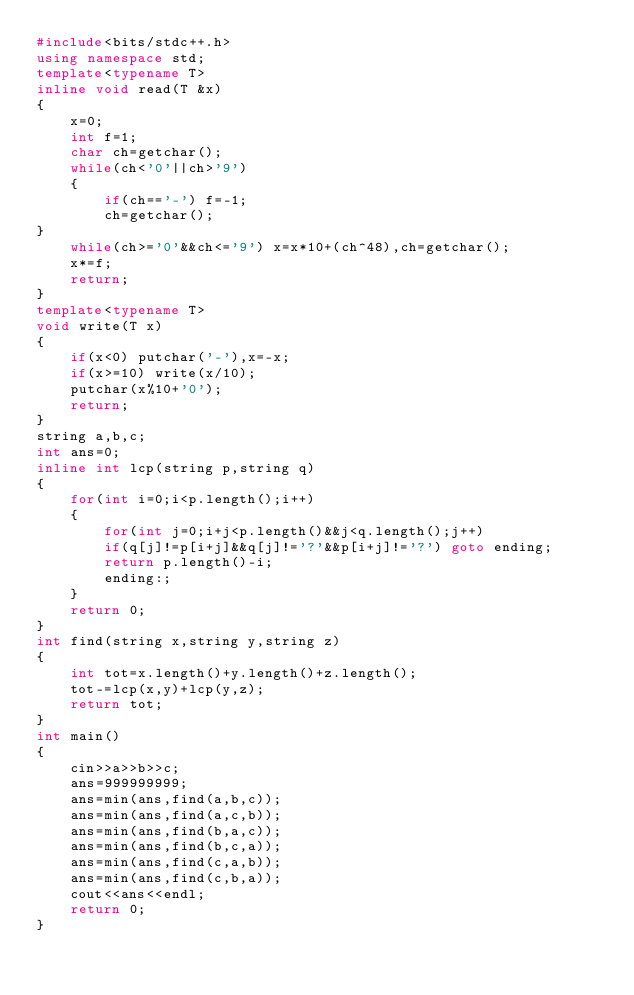<code> <loc_0><loc_0><loc_500><loc_500><_C++_>#include<bits/stdc++.h>
using namespace std;
template<typename T>
inline void read(T &x)
{
	x=0;
	int f=1;
	char ch=getchar();
	while(ch<'0'||ch>'9')
	{
		if(ch=='-') f=-1;
		ch=getchar();
}
	while(ch>='0'&&ch<='9') x=x*10+(ch^48),ch=getchar();
	x*=f;
	return;
}	
template<typename T>
void write(T x)
{
	if(x<0) putchar('-'),x=-x;
	if(x>=10) write(x/10);
	putchar(x%10+'0');
	return;
}
string a,b,c;
int ans=0;
inline int lcp(string p,string q)
{
    for(int i=0;i<p.length();i++)
    {
        for(int j=0;i+j<p.length()&&j<q.length();j++)
        if(q[j]!=p[i+j]&&q[j]!='?'&&p[i+j]!='?') goto ending;
        return p.length()-i;
        ending:;
    }
    return 0;
}
int find(string x,string y,string z)
{
    int tot=x.length()+y.length()+z.length();
    tot-=lcp(x,y)+lcp(y,z);
    return tot;
}
int main()
{
    cin>>a>>b>>c;
    ans=999999999;
    ans=min(ans,find(a,b,c));
    ans=min(ans,find(a,c,b));
    ans=min(ans,find(b,a,c));
    ans=min(ans,find(b,c,a));
    ans=min(ans,find(c,a,b));
    ans=min(ans,find(c,b,a));
    cout<<ans<<endl;
	return 0;
}
</code> 